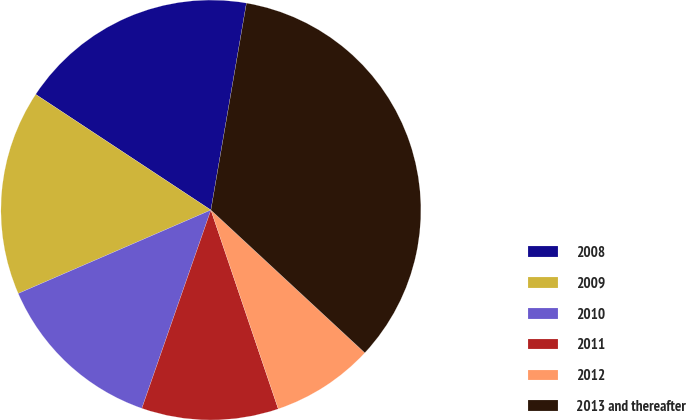Convert chart to OTSL. <chart><loc_0><loc_0><loc_500><loc_500><pie_chart><fcel>2008<fcel>2009<fcel>2010<fcel>2011<fcel>2012<fcel>2013 and thereafter<nl><fcel>18.42%<fcel>15.79%<fcel>13.16%<fcel>10.53%<fcel>7.9%<fcel>34.19%<nl></chart> 